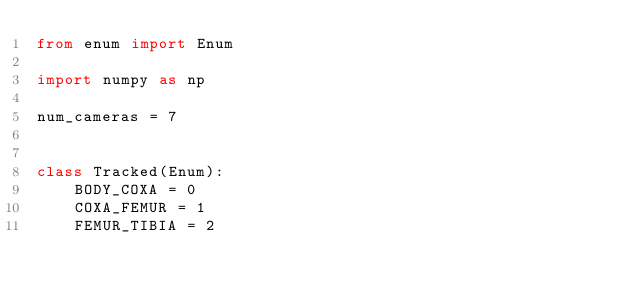Convert code to text. <code><loc_0><loc_0><loc_500><loc_500><_Python_>from enum import Enum

import numpy as np

num_cameras = 7


class Tracked(Enum):
    BODY_COXA = 0
    COXA_FEMUR = 1
    FEMUR_TIBIA = 2</code> 